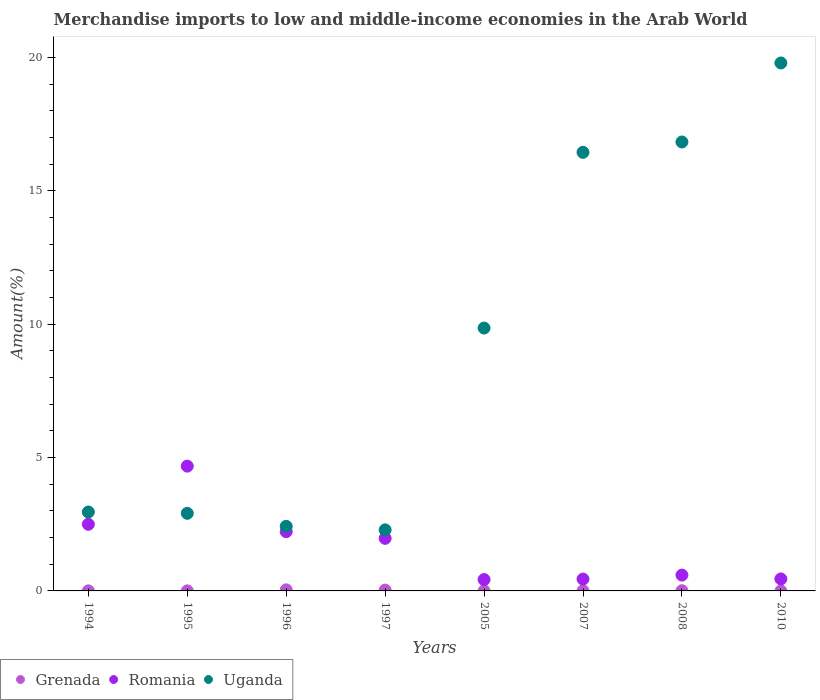Is the number of dotlines equal to the number of legend labels?
Offer a terse response. Yes. What is the percentage of amount earned from merchandise imports in Grenada in 2005?
Give a very brief answer. 0. Across all years, what is the maximum percentage of amount earned from merchandise imports in Uganda?
Your answer should be very brief. 19.8. Across all years, what is the minimum percentage of amount earned from merchandise imports in Grenada?
Make the answer very short. 6.59134036777357e-5. What is the total percentage of amount earned from merchandise imports in Uganda in the graph?
Provide a short and direct response. 73.52. What is the difference between the percentage of amount earned from merchandise imports in Uganda in 2005 and that in 2008?
Your answer should be compact. -6.98. What is the difference between the percentage of amount earned from merchandise imports in Romania in 1995 and the percentage of amount earned from merchandise imports in Uganda in 1996?
Your answer should be very brief. 2.26. What is the average percentage of amount earned from merchandise imports in Uganda per year?
Ensure brevity in your answer.  9.19. In the year 2005, what is the difference between the percentage of amount earned from merchandise imports in Romania and percentage of amount earned from merchandise imports in Uganda?
Give a very brief answer. -9.43. In how many years, is the percentage of amount earned from merchandise imports in Uganda greater than 10 %?
Ensure brevity in your answer.  3. What is the ratio of the percentage of amount earned from merchandise imports in Romania in 1994 to that in 1996?
Keep it short and to the point. 1.12. What is the difference between the highest and the second highest percentage of amount earned from merchandise imports in Uganda?
Keep it short and to the point. 2.96. What is the difference between the highest and the lowest percentage of amount earned from merchandise imports in Uganda?
Your answer should be very brief. 17.51. In how many years, is the percentage of amount earned from merchandise imports in Uganda greater than the average percentage of amount earned from merchandise imports in Uganda taken over all years?
Your answer should be compact. 4. Is it the case that in every year, the sum of the percentage of amount earned from merchandise imports in Grenada and percentage of amount earned from merchandise imports in Romania  is greater than the percentage of amount earned from merchandise imports in Uganda?
Ensure brevity in your answer.  No. Is the percentage of amount earned from merchandise imports in Romania strictly less than the percentage of amount earned from merchandise imports in Grenada over the years?
Provide a succinct answer. No. How many dotlines are there?
Offer a terse response. 3. How many years are there in the graph?
Give a very brief answer. 8. What is the difference between two consecutive major ticks on the Y-axis?
Make the answer very short. 5. Are the values on the major ticks of Y-axis written in scientific E-notation?
Ensure brevity in your answer.  No. Does the graph contain any zero values?
Your response must be concise. No. How many legend labels are there?
Give a very brief answer. 3. How are the legend labels stacked?
Your response must be concise. Horizontal. What is the title of the graph?
Keep it short and to the point. Merchandise imports to low and middle-income economies in the Arab World. What is the label or title of the X-axis?
Offer a very short reply. Years. What is the label or title of the Y-axis?
Provide a short and direct response. Amount(%). What is the Amount(%) in Grenada in 1994?
Make the answer very short. 0. What is the Amount(%) in Romania in 1994?
Keep it short and to the point. 2.5. What is the Amount(%) in Uganda in 1994?
Your answer should be very brief. 2.96. What is the Amount(%) of Grenada in 1995?
Ensure brevity in your answer.  0. What is the Amount(%) in Romania in 1995?
Your response must be concise. 4.68. What is the Amount(%) in Uganda in 1995?
Your answer should be compact. 2.91. What is the Amount(%) of Grenada in 1996?
Ensure brevity in your answer.  0.04. What is the Amount(%) in Romania in 1996?
Offer a very short reply. 2.22. What is the Amount(%) of Uganda in 1996?
Make the answer very short. 2.42. What is the Amount(%) of Grenada in 1997?
Offer a terse response. 0.03. What is the Amount(%) of Romania in 1997?
Keep it short and to the point. 1.97. What is the Amount(%) of Uganda in 1997?
Your answer should be very brief. 2.29. What is the Amount(%) of Grenada in 2005?
Provide a succinct answer. 0. What is the Amount(%) of Romania in 2005?
Your answer should be very brief. 0.43. What is the Amount(%) in Uganda in 2005?
Your response must be concise. 9.86. What is the Amount(%) of Grenada in 2007?
Ensure brevity in your answer.  0.01. What is the Amount(%) of Romania in 2007?
Offer a very short reply. 0.44. What is the Amount(%) in Uganda in 2007?
Your answer should be compact. 16.45. What is the Amount(%) of Grenada in 2008?
Give a very brief answer. 0.01. What is the Amount(%) in Romania in 2008?
Ensure brevity in your answer.  0.59. What is the Amount(%) of Uganda in 2008?
Offer a terse response. 16.84. What is the Amount(%) of Grenada in 2010?
Keep it short and to the point. 6.59134036777357e-5. What is the Amount(%) in Romania in 2010?
Provide a succinct answer. 0.45. What is the Amount(%) of Uganda in 2010?
Offer a terse response. 19.8. Across all years, what is the maximum Amount(%) in Grenada?
Your answer should be very brief. 0.04. Across all years, what is the maximum Amount(%) of Romania?
Your answer should be very brief. 4.68. Across all years, what is the maximum Amount(%) of Uganda?
Give a very brief answer. 19.8. Across all years, what is the minimum Amount(%) of Grenada?
Offer a very short reply. 6.59134036777357e-5. Across all years, what is the minimum Amount(%) in Romania?
Your response must be concise. 0.43. Across all years, what is the minimum Amount(%) of Uganda?
Make the answer very short. 2.29. What is the total Amount(%) in Grenada in the graph?
Provide a short and direct response. 0.09. What is the total Amount(%) in Romania in the graph?
Your answer should be very brief. 13.29. What is the total Amount(%) of Uganda in the graph?
Ensure brevity in your answer.  73.52. What is the difference between the Amount(%) of Romania in 1994 and that in 1995?
Provide a succinct answer. -2.18. What is the difference between the Amount(%) of Uganda in 1994 and that in 1995?
Offer a terse response. 0.05. What is the difference between the Amount(%) in Grenada in 1994 and that in 1996?
Your answer should be compact. -0.04. What is the difference between the Amount(%) in Romania in 1994 and that in 1996?
Give a very brief answer. 0.28. What is the difference between the Amount(%) in Uganda in 1994 and that in 1996?
Provide a short and direct response. 0.54. What is the difference between the Amount(%) in Grenada in 1994 and that in 1997?
Your answer should be compact. -0.03. What is the difference between the Amount(%) in Romania in 1994 and that in 1997?
Your answer should be very brief. 0.53. What is the difference between the Amount(%) of Uganda in 1994 and that in 1997?
Your answer should be very brief. 0.67. What is the difference between the Amount(%) of Grenada in 1994 and that in 2005?
Your answer should be very brief. -0. What is the difference between the Amount(%) of Romania in 1994 and that in 2005?
Your response must be concise. 2.07. What is the difference between the Amount(%) in Uganda in 1994 and that in 2005?
Provide a succinct answer. -6.9. What is the difference between the Amount(%) of Grenada in 1994 and that in 2007?
Provide a succinct answer. -0. What is the difference between the Amount(%) in Romania in 1994 and that in 2007?
Your answer should be compact. 2.05. What is the difference between the Amount(%) in Uganda in 1994 and that in 2007?
Make the answer very short. -13.49. What is the difference between the Amount(%) of Grenada in 1994 and that in 2008?
Give a very brief answer. -0. What is the difference between the Amount(%) of Romania in 1994 and that in 2008?
Ensure brevity in your answer.  1.9. What is the difference between the Amount(%) in Uganda in 1994 and that in 2008?
Your response must be concise. -13.88. What is the difference between the Amount(%) in Grenada in 1994 and that in 2010?
Give a very brief answer. 0. What is the difference between the Amount(%) of Romania in 1994 and that in 2010?
Give a very brief answer. 2.05. What is the difference between the Amount(%) of Uganda in 1994 and that in 2010?
Ensure brevity in your answer.  -16.84. What is the difference between the Amount(%) of Grenada in 1995 and that in 1996?
Your answer should be compact. -0.04. What is the difference between the Amount(%) in Romania in 1995 and that in 1996?
Provide a short and direct response. 2.46. What is the difference between the Amount(%) of Uganda in 1995 and that in 1996?
Offer a very short reply. 0.49. What is the difference between the Amount(%) in Grenada in 1995 and that in 1997?
Give a very brief answer. -0.03. What is the difference between the Amount(%) of Romania in 1995 and that in 1997?
Your response must be concise. 2.71. What is the difference between the Amount(%) of Uganda in 1995 and that in 1997?
Your answer should be compact. 0.62. What is the difference between the Amount(%) in Grenada in 1995 and that in 2005?
Your answer should be very brief. -0. What is the difference between the Amount(%) in Romania in 1995 and that in 2005?
Ensure brevity in your answer.  4.25. What is the difference between the Amount(%) in Uganda in 1995 and that in 2005?
Make the answer very short. -6.95. What is the difference between the Amount(%) of Grenada in 1995 and that in 2007?
Your answer should be compact. -0. What is the difference between the Amount(%) in Romania in 1995 and that in 2007?
Offer a terse response. 4.24. What is the difference between the Amount(%) of Uganda in 1995 and that in 2007?
Keep it short and to the point. -13.54. What is the difference between the Amount(%) of Grenada in 1995 and that in 2008?
Make the answer very short. -0. What is the difference between the Amount(%) of Romania in 1995 and that in 2008?
Your answer should be very brief. 4.09. What is the difference between the Amount(%) of Uganda in 1995 and that in 2008?
Offer a very short reply. -13.93. What is the difference between the Amount(%) of Grenada in 1995 and that in 2010?
Keep it short and to the point. 0. What is the difference between the Amount(%) of Romania in 1995 and that in 2010?
Keep it short and to the point. 4.23. What is the difference between the Amount(%) of Uganda in 1995 and that in 2010?
Keep it short and to the point. -16.89. What is the difference between the Amount(%) in Grenada in 1996 and that in 1997?
Your answer should be very brief. 0.01. What is the difference between the Amount(%) in Romania in 1996 and that in 1997?
Your answer should be compact. 0.25. What is the difference between the Amount(%) of Uganda in 1996 and that in 1997?
Your response must be concise. 0.13. What is the difference between the Amount(%) of Grenada in 1996 and that in 2005?
Your answer should be compact. 0.04. What is the difference between the Amount(%) of Romania in 1996 and that in 2005?
Provide a short and direct response. 1.8. What is the difference between the Amount(%) in Uganda in 1996 and that in 2005?
Offer a very short reply. -7.44. What is the difference between the Amount(%) in Grenada in 1996 and that in 2007?
Give a very brief answer. 0.04. What is the difference between the Amount(%) of Romania in 1996 and that in 2007?
Offer a terse response. 1.78. What is the difference between the Amount(%) of Uganda in 1996 and that in 2007?
Provide a succinct answer. -14.02. What is the difference between the Amount(%) of Grenada in 1996 and that in 2008?
Provide a short and direct response. 0.03. What is the difference between the Amount(%) of Romania in 1996 and that in 2008?
Provide a short and direct response. 1.63. What is the difference between the Amount(%) in Uganda in 1996 and that in 2008?
Provide a short and direct response. -14.41. What is the difference between the Amount(%) in Grenada in 1996 and that in 2010?
Make the answer very short. 0.04. What is the difference between the Amount(%) of Romania in 1996 and that in 2010?
Provide a short and direct response. 1.77. What is the difference between the Amount(%) of Uganda in 1996 and that in 2010?
Offer a very short reply. -17.38. What is the difference between the Amount(%) in Grenada in 1997 and that in 2005?
Offer a very short reply. 0.03. What is the difference between the Amount(%) in Romania in 1997 and that in 2005?
Make the answer very short. 1.55. What is the difference between the Amount(%) of Uganda in 1997 and that in 2005?
Your answer should be compact. -7.57. What is the difference between the Amount(%) of Grenada in 1997 and that in 2007?
Provide a short and direct response. 0.03. What is the difference between the Amount(%) of Romania in 1997 and that in 2007?
Provide a succinct answer. 1.53. What is the difference between the Amount(%) of Uganda in 1997 and that in 2007?
Keep it short and to the point. -14.16. What is the difference between the Amount(%) of Grenada in 1997 and that in 2008?
Your response must be concise. 0.02. What is the difference between the Amount(%) in Romania in 1997 and that in 2008?
Your response must be concise. 1.38. What is the difference between the Amount(%) in Uganda in 1997 and that in 2008?
Ensure brevity in your answer.  -14.54. What is the difference between the Amount(%) in Grenada in 1997 and that in 2010?
Your response must be concise. 0.03. What is the difference between the Amount(%) in Romania in 1997 and that in 2010?
Provide a succinct answer. 1.52. What is the difference between the Amount(%) in Uganda in 1997 and that in 2010?
Keep it short and to the point. -17.51. What is the difference between the Amount(%) in Grenada in 2005 and that in 2007?
Keep it short and to the point. -0. What is the difference between the Amount(%) in Romania in 2005 and that in 2007?
Make the answer very short. -0.02. What is the difference between the Amount(%) in Uganda in 2005 and that in 2007?
Your answer should be very brief. -6.59. What is the difference between the Amount(%) in Grenada in 2005 and that in 2008?
Provide a succinct answer. -0. What is the difference between the Amount(%) in Romania in 2005 and that in 2008?
Your answer should be very brief. -0.17. What is the difference between the Amount(%) of Uganda in 2005 and that in 2008?
Your response must be concise. -6.98. What is the difference between the Amount(%) of Grenada in 2005 and that in 2010?
Provide a succinct answer. 0. What is the difference between the Amount(%) in Romania in 2005 and that in 2010?
Your answer should be very brief. -0.02. What is the difference between the Amount(%) of Uganda in 2005 and that in 2010?
Ensure brevity in your answer.  -9.94. What is the difference between the Amount(%) of Grenada in 2007 and that in 2008?
Keep it short and to the point. -0. What is the difference between the Amount(%) of Romania in 2007 and that in 2008?
Provide a short and direct response. -0.15. What is the difference between the Amount(%) of Uganda in 2007 and that in 2008?
Give a very brief answer. -0.39. What is the difference between the Amount(%) of Grenada in 2007 and that in 2010?
Offer a terse response. 0.01. What is the difference between the Amount(%) of Romania in 2007 and that in 2010?
Provide a succinct answer. -0.01. What is the difference between the Amount(%) of Uganda in 2007 and that in 2010?
Keep it short and to the point. -3.35. What is the difference between the Amount(%) in Grenada in 2008 and that in 2010?
Make the answer very short. 0.01. What is the difference between the Amount(%) of Romania in 2008 and that in 2010?
Ensure brevity in your answer.  0.14. What is the difference between the Amount(%) in Uganda in 2008 and that in 2010?
Provide a succinct answer. -2.96. What is the difference between the Amount(%) of Grenada in 1994 and the Amount(%) of Romania in 1995?
Offer a terse response. -4.68. What is the difference between the Amount(%) of Grenada in 1994 and the Amount(%) of Uganda in 1995?
Your response must be concise. -2.91. What is the difference between the Amount(%) of Romania in 1994 and the Amount(%) of Uganda in 1995?
Offer a very short reply. -0.41. What is the difference between the Amount(%) in Grenada in 1994 and the Amount(%) in Romania in 1996?
Ensure brevity in your answer.  -2.22. What is the difference between the Amount(%) in Grenada in 1994 and the Amount(%) in Uganda in 1996?
Offer a very short reply. -2.42. What is the difference between the Amount(%) of Romania in 1994 and the Amount(%) of Uganda in 1996?
Provide a short and direct response. 0.08. What is the difference between the Amount(%) of Grenada in 1994 and the Amount(%) of Romania in 1997?
Give a very brief answer. -1.97. What is the difference between the Amount(%) of Grenada in 1994 and the Amount(%) of Uganda in 1997?
Your answer should be compact. -2.29. What is the difference between the Amount(%) of Romania in 1994 and the Amount(%) of Uganda in 1997?
Offer a terse response. 0.21. What is the difference between the Amount(%) of Grenada in 1994 and the Amount(%) of Romania in 2005?
Keep it short and to the point. -0.42. What is the difference between the Amount(%) in Grenada in 1994 and the Amount(%) in Uganda in 2005?
Offer a terse response. -9.86. What is the difference between the Amount(%) of Romania in 1994 and the Amount(%) of Uganda in 2005?
Offer a very short reply. -7.36. What is the difference between the Amount(%) in Grenada in 1994 and the Amount(%) in Romania in 2007?
Keep it short and to the point. -0.44. What is the difference between the Amount(%) in Grenada in 1994 and the Amount(%) in Uganda in 2007?
Your response must be concise. -16.44. What is the difference between the Amount(%) in Romania in 1994 and the Amount(%) in Uganda in 2007?
Give a very brief answer. -13.95. What is the difference between the Amount(%) in Grenada in 1994 and the Amount(%) in Romania in 2008?
Your answer should be very brief. -0.59. What is the difference between the Amount(%) in Grenada in 1994 and the Amount(%) in Uganda in 2008?
Ensure brevity in your answer.  -16.83. What is the difference between the Amount(%) of Romania in 1994 and the Amount(%) of Uganda in 2008?
Offer a very short reply. -14.34. What is the difference between the Amount(%) of Grenada in 1994 and the Amount(%) of Romania in 2010?
Your response must be concise. -0.45. What is the difference between the Amount(%) in Grenada in 1994 and the Amount(%) in Uganda in 2010?
Provide a succinct answer. -19.8. What is the difference between the Amount(%) of Romania in 1994 and the Amount(%) of Uganda in 2010?
Keep it short and to the point. -17.3. What is the difference between the Amount(%) of Grenada in 1995 and the Amount(%) of Romania in 1996?
Provide a short and direct response. -2.22. What is the difference between the Amount(%) in Grenada in 1995 and the Amount(%) in Uganda in 1996?
Offer a very short reply. -2.42. What is the difference between the Amount(%) of Romania in 1995 and the Amount(%) of Uganda in 1996?
Give a very brief answer. 2.26. What is the difference between the Amount(%) in Grenada in 1995 and the Amount(%) in Romania in 1997?
Offer a very short reply. -1.97. What is the difference between the Amount(%) of Grenada in 1995 and the Amount(%) of Uganda in 1997?
Offer a terse response. -2.29. What is the difference between the Amount(%) in Romania in 1995 and the Amount(%) in Uganda in 1997?
Offer a terse response. 2.39. What is the difference between the Amount(%) in Grenada in 1995 and the Amount(%) in Romania in 2005?
Provide a short and direct response. -0.42. What is the difference between the Amount(%) of Grenada in 1995 and the Amount(%) of Uganda in 2005?
Ensure brevity in your answer.  -9.86. What is the difference between the Amount(%) in Romania in 1995 and the Amount(%) in Uganda in 2005?
Your response must be concise. -5.18. What is the difference between the Amount(%) in Grenada in 1995 and the Amount(%) in Romania in 2007?
Provide a succinct answer. -0.44. What is the difference between the Amount(%) of Grenada in 1995 and the Amount(%) of Uganda in 2007?
Provide a succinct answer. -16.45. What is the difference between the Amount(%) of Romania in 1995 and the Amount(%) of Uganda in 2007?
Make the answer very short. -11.77. What is the difference between the Amount(%) in Grenada in 1995 and the Amount(%) in Romania in 2008?
Offer a very short reply. -0.59. What is the difference between the Amount(%) of Grenada in 1995 and the Amount(%) of Uganda in 2008?
Provide a succinct answer. -16.83. What is the difference between the Amount(%) of Romania in 1995 and the Amount(%) of Uganda in 2008?
Keep it short and to the point. -12.16. What is the difference between the Amount(%) in Grenada in 1995 and the Amount(%) in Romania in 2010?
Give a very brief answer. -0.45. What is the difference between the Amount(%) in Grenada in 1995 and the Amount(%) in Uganda in 2010?
Provide a succinct answer. -19.8. What is the difference between the Amount(%) of Romania in 1995 and the Amount(%) of Uganda in 2010?
Offer a terse response. -15.12. What is the difference between the Amount(%) in Grenada in 1996 and the Amount(%) in Romania in 1997?
Offer a very short reply. -1.93. What is the difference between the Amount(%) of Grenada in 1996 and the Amount(%) of Uganda in 1997?
Give a very brief answer. -2.25. What is the difference between the Amount(%) of Romania in 1996 and the Amount(%) of Uganda in 1997?
Offer a terse response. -0.07. What is the difference between the Amount(%) in Grenada in 1996 and the Amount(%) in Romania in 2005?
Provide a short and direct response. -0.39. What is the difference between the Amount(%) of Grenada in 1996 and the Amount(%) of Uganda in 2005?
Make the answer very short. -9.82. What is the difference between the Amount(%) in Romania in 1996 and the Amount(%) in Uganda in 2005?
Your response must be concise. -7.64. What is the difference between the Amount(%) in Grenada in 1996 and the Amount(%) in Romania in 2007?
Provide a succinct answer. -0.4. What is the difference between the Amount(%) of Grenada in 1996 and the Amount(%) of Uganda in 2007?
Provide a succinct answer. -16.41. What is the difference between the Amount(%) of Romania in 1996 and the Amount(%) of Uganda in 2007?
Your response must be concise. -14.22. What is the difference between the Amount(%) of Grenada in 1996 and the Amount(%) of Romania in 2008?
Offer a very short reply. -0.55. What is the difference between the Amount(%) of Grenada in 1996 and the Amount(%) of Uganda in 2008?
Your answer should be very brief. -16.79. What is the difference between the Amount(%) in Romania in 1996 and the Amount(%) in Uganda in 2008?
Provide a succinct answer. -14.61. What is the difference between the Amount(%) of Grenada in 1996 and the Amount(%) of Romania in 2010?
Provide a short and direct response. -0.41. What is the difference between the Amount(%) in Grenada in 1996 and the Amount(%) in Uganda in 2010?
Provide a succinct answer. -19.76. What is the difference between the Amount(%) in Romania in 1996 and the Amount(%) in Uganda in 2010?
Make the answer very short. -17.58. What is the difference between the Amount(%) of Grenada in 1997 and the Amount(%) of Romania in 2005?
Your response must be concise. -0.4. What is the difference between the Amount(%) of Grenada in 1997 and the Amount(%) of Uganda in 2005?
Make the answer very short. -9.83. What is the difference between the Amount(%) in Romania in 1997 and the Amount(%) in Uganda in 2005?
Provide a short and direct response. -7.89. What is the difference between the Amount(%) of Grenada in 1997 and the Amount(%) of Romania in 2007?
Provide a succinct answer. -0.41. What is the difference between the Amount(%) of Grenada in 1997 and the Amount(%) of Uganda in 2007?
Make the answer very short. -16.42. What is the difference between the Amount(%) of Romania in 1997 and the Amount(%) of Uganda in 2007?
Ensure brevity in your answer.  -14.48. What is the difference between the Amount(%) in Grenada in 1997 and the Amount(%) in Romania in 2008?
Provide a succinct answer. -0.56. What is the difference between the Amount(%) of Grenada in 1997 and the Amount(%) of Uganda in 2008?
Provide a short and direct response. -16.8. What is the difference between the Amount(%) of Romania in 1997 and the Amount(%) of Uganda in 2008?
Provide a short and direct response. -14.86. What is the difference between the Amount(%) in Grenada in 1997 and the Amount(%) in Romania in 2010?
Give a very brief answer. -0.42. What is the difference between the Amount(%) in Grenada in 1997 and the Amount(%) in Uganda in 2010?
Make the answer very short. -19.77. What is the difference between the Amount(%) in Romania in 1997 and the Amount(%) in Uganda in 2010?
Offer a very short reply. -17.83. What is the difference between the Amount(%) in Grenada in 2005 and the Amount(%) in Romania in 2007?
Your response must be concise. -0.44. What is the difference between the Amount(%) of Grenada in 2005 and the Amount(%) of Uganda in 2007?
Give a very brief answer. -16.44. What is the difference between the Amount(%) in Romania in 2005 and the Amount(%) in Uganda in 2007?
Provide a short and direct response. -16.02. What is the difference between the Amount(%) in Grenada in 2005 and the Amount(%) in Romania in 2008?
Ensure brevity in your answer.  -0.59. What is the difference between the Amount(%) of Grenada in 2005 and the Amount(%) of Uganda in 2008?
Offer a very short reply. -16.83. What is the difference between the Amount(%) in Romania in 2005 and the Amount(%) in Uganda in 2008?
Your response must be concise. -16.41. What is the difference between the Amount(%) of Grenada in 2005 and the Amount(%) of Romania in 2010?
Your answer should be compact. -0.45. What is the difference between the Amount(%) of Grenada in 2005 and the Amount(%) of Uganda in 2010?
Give a very brief answer. -19.79. What is the difference between the Amount(%) of Romania in 2005 and the Amount(%) of Uganda in 2010?
Your response must be concise. -19.37. What is the difference between the Amount(%) in Grenada in 2007 and the Amount(%) in Romania in 2008?
Make the answer very short. -0.59. What is the difference between the Amount(%) of Grenada in 2007 and the Amount(%) of Uganda in 2008?
Provide a short and direct response. -16.83. What is the difference between the Amount(%) in Romania in 2007 and the Amount(%) in Uganda in 2008?
Give a very brief answer. -16.39. What is the difference between the Amount(%) in Grenada in 2007 and the Amount(%) in Romania in 2010?
Provide a short and direct response. -0.44. What is the difference between the Amount(%) in Grenada in 2007 and the Amount(%) in Uganda in 2010?
Your answer should be compact. -19.79. What is the difference between the Amount(%) of Romania in 2007 and the Amount(%) of Uganda in 2010?
Provide a short and direct response. -19.35. What is the difference between the Amount(%) of Grenada in 2008 and the Amount(%) of Romania in 2010?
Offer a terse response. -0.44. What is the difference between the Amount(%) of Grenada in 2008 and the Amount(%) of Uganda in 2010?
Give a very brief answer. -19.79. What is the difference between the Amount(%) in Romania in 2008 and the Amount(%) in Uganda in 2010?
Provide a succinct answer. -19.2. What is the average Amount(%) of Grenada per year?
Provide a short and direct response. 0.01. What is the average Amount(%) of Romania per year?
Provide a succinct answer. 1.66. What is the average Amount(%) of Uganda per year?
Your answer should be compact. 9.19. In the year 1994, what is the difference between the Amount(%) of Grenada and Amount(%) of Romania?
Keep it short and to the point. -2.5. In the year 1994, what is the difference between the Amount(%) of Grenada and Amount(%) of Uganda?
Your response must be concise. -2.96. In the year 1994, what is the difference between the Amount(%) in Romania and Amount(%) in Uganda?
Make the answer very short. -0.46. In the year 1995, what is the difference between the Amount(%) in Grenada and Amount(%) in Romania?
Offer a very short reply. -4.68. In the year 1995, what is the difference between the Amount(%) of Grenada and Amount(%) of Uganda?
Make the answer very short. -2.91. In the year 1995, what is the difference between the Amount(%) of Romania and Amount(%) of Uganda?
Give a very brief answer. 1.77. In the year 1996, what is the difference between the Amount(%) in Grenada and Amount(%) in Romania?
Keep it short and to the point. -2.18. In the year 1996, what is the difference between the Amount(%) of Grenada and Amount(%) of Uganda?
Your answer should be compact. -2.38. In the year 1996, what is the difference between the Amount(%) of Romania and Amount(%) of Uganda?
Offer a terse response. -0.2. In the year 1997, what is the difference between the Amount(%) in Grenada and Amount(%) in Romania?
Your response must be concise. -1.94. In the year 1997, what is the difference between the Amount(%) in Grenada and Amount(%) in Uganda?
Provide a succinct answer. -2.26. In the year 1997, what is the difference between the Amount(%) of Romania and Amount(%) of Uganda?
Offer a very short reply. -0.32. In the year 2005, what is the difference between the Amount(%) in Grenada and Amount(%) in Romania?
Give a very brief answer. -0.42. In the year 2005, what is the difference between the Amount(%) of Grenada and Amount(%) of Uganda?
Provide a succinct answer. -9.85. In the year 2005, what is the difference between the Amount(%) in Romania and Amount(%) in Uganda?
Provide a short and direct response. -9.43. In the year 2007, what is the difference between the Amount(%) in Grenada and Amount(%) in Romania?
Your answer should be very brief. -0.44. In the year 2007, what is the difference between the Amount(%) of Grenada and Amount(%) of Uganda?
Give a very brief answer. -16.44. In the year 2007, what is the difference between the Amount(%) in Romania and Amount(%) in Uganda?
Your answer should be compact. -16. In the year 2008, what is the difference between the Amount(%) of Grenada and Amount(%) of Romania?
Make the answer very short. -0.59. In the year 2008, what is the difference between the Amount(%) in Grenada and Amount(%) in Uganda?
Your answer should be compact. -16.83. In the year 2008, what is the difference between the Amount(%) in Romania and Amount(%) in Uganda?
Make the answer very short. -16.24. In the year 2010, what is the difference between the Amount(%) of Grenada and Amount(%) of Romania?
Make the answer very short. -0.45. In the year 2010, what is the difference between the Amount(%) of Grenada and Amount(%) of Uganda?
Your answer should be very brief. -19.8. In the year 2010, what is the difference between the Amount(%) of Romania and Amount(%) of Uganda?
Ensure brevity in your answer.  -19.35. What is the ratio of the Amount(%) of Grenada in 1994 to that in 1995?
Your answer should be compact. 1.19. What is the ratio of the Amount(%) in Romania in 1994 to that in 1995?
Provide a succinct answer. 0.53. What is the ratio of the Amount(%) in Uganda in 1994 to that in 1995?
Your response must be concise. 1.02. What is the ratio of the Amount(%) of Grenada in 1994 to that in 1996?
Your answer should be very brief. 0.06. What is the ratio of the Amount(%) of Romania in 1994 to that in 1996?
Ensure brevity in your answer.  1.12. What is the ratio of the Amount(%) in Uganda in 1994 to that in 1996?
Offer a terse response. 1.22. What is the ratio of the Amount(%) in Grenada in 1994 to that in 1997?
Provide a short and direct response. 0.08. What is the ratio of the Amount(%) in Romania in 1994 to that in 1997?
Provide a succinct answer. 1.27. What is the ratio of the Amount(%) of Uganda in 1994 to that in 1997?
Offer a very short reply. 1.29. What is the ratio of the Amount(%) of Grenada in 1994 to that in 2005?
Make the answer very short. 0.5. What is the ratio of the Amount(%) of Romania in 1994 to that in 2005?
Offer a very short reply. 5.86. What is the ratio of the Amount(%) in Uganda in 1994 to that in 2005?
Provide a short and direct response. 0.3. What is the ratio of the Amount(%) in Grenada in 1994 to that in 2007?
Offer a very short reply. 0.39. What is the ratio of the Amount(%) in Romania in 1994 to that in 2007?
Provide a short and direct response. 5.62. What is the ratio of the Amount(%) of Uganda in 1994 to that in 2007?
Offer a terse response. 0.18. What is the ratio of the Amount(%) in Grenada in 1994 to that in 2008?
Your response must be concise. 0.35. What is the ratio of the Amount(%) of Romania in 1994 to that in 2008?
Offer a very short reply. 4.21. What is the ratio of the Amount(%) in Uganda in 1994 to that in 2008?
Your answer should be very brief. 0.18. What is the ratio of the Amount(%) in Grenada in 1994 to that in 2010?
Make the answer very short. 35.23. What is the ratio of the Amount(%) in Romania in 1994 to that in 2010?
Provide a short and direct response. 5.55. What is the ratio of the Amount(%) of Uganda in 1994 to that in 2010?
Keep it short and to the point. 0.15. What is the ratio of the Amount(%) in Grenada in 1995 to that in 1996?
Make the answer very short. 0.05. What is the ratio of the Amount(%) of Romania in 1995 to that in 1996?
Offer a terse response. 2.11. What is the ratio of the Amount(%) of Uganda in 1995 to that in 1996?
Ensure brevity in your answer.  1.2. What is the ratio of the Amount(%) of Grenada in 1995 to that in 1997?
Give a very brief answer. 0.06. What is the ratio of the Amount(%) in Romania in 1995 to that in 1997?
Your response must be concise. 2.37. What is the ratio of the Amount(%) of Uganda in 1995 to that in 1997?
Give a very brief answer. 1.27. What is the ratio of the Amount(%) in Grenada in 1995 to that in 2005?
Your answer should be very brief. 0.42. What is the ratio of the Amount(%) in Romania in 1995 to that in 2005?
Provide a succinct answer. 10.98. What is the ratio of the Amount(%) of Uganda in 1995 to that in 2005?
Make the answer very short. 0.3. What is the ratio of the Amount(%) in Grenada in 1995 to that in 2007?
Your answer should be compact. 0.33. What is the ratio of the Amount(%) of Romania in 1995 to that in 2007?
Keep it short and to the point. 10.53. What is the ratio of the Amount(%) in Uganda in 1995 to that in 2007?
Keep it short and to the point. 0.18. What is the ratio of the Amount(%) of Grenada in 1995 to that in 2008?
Ensure brevity in your answer.  0.29. What is the ratio of the Amount(%) of Romania in 1995 to that in 2008?
Your answer should be compact. 7.88. What is the ratio of the Amount(%) in Uganda in 1995 to that in 2008?
Your answer should be very brief. 0.17. What is the ratio of the Amount(%) in Grenada in 1995 to that in 2010?
Give a very brief answer. 29.69. What is the ratio of the Amount(%) in Romania in 1995 to that in 2010?
Make the answer very short. 10.4. What is the ratio of the Amount(%) in Uganda in 1995 to that in 2010?
Offer a terse response. 0.15. What is the ratio of the Amount(%) in Grenada in 1996 to that in 1997?
Your response must be concise. 1.33. What is the ratio of the Amount(%) of Romania in 1996 to that in 1997?
Make the answer very short. 1.13. What is the ratio of the Amount(%) of Uganda in 1996 to that in 1997?
Ensure brevity in your answer.  1.06. What is the ratio of the Amount(%) of Grenada in 1996 to that in 2005?
Offer a terse response. 8.86. What is the ratio of the Amount(%) of Romania in 1996 to that in 2005?
Your response must be concise. 5.21. What is the ratio of the Amount(%) in Uganda in 1996 to that in 2005?
Offer a very short reply. 0.25. What is the ratio of the Amount(%) in Grenada in 1996 to that in 2007?
Your response must be concise. 6.94. What is the ratio of the Amount(%) of Romania in 1996 to that in 2007?
Your response must be concise. 5. What is the ratio of the Amount(%) of Uganda in 1996 to that in 2007?
Provide a succinct answer. 0.15. What is the ratio of the Amount(%) of Grenada in 1996 to that in 2008?
Offer a terse response. 6.15. What is the ratio of the Amount(%) of Romania in 1996 to that in 2008?
Provide a short and direct response. 3.74. What is the ratio of the Amount(%) of Uganda in 1996 to that in 2008?
Make the answer very short. 0.14. What is the ratio of the Amount(%) in Grenada in 1996 to that in 2010?
Offer a terse response. 625.88. What is the ratio of the Amount(%) in Romania in 1996 to that in 2010?
Keep it short and to the point. 4.94. What is the ratio of the Amount(%) of Uganda in 1996 to that in 2010?
Provide a short and direct response. 0.12. What is the ratio of the Amount(%) of Grenada in 1997 to that in 2005?
Offer a terse response. 6.64. What is the ratio of the Amount(%) of Romania in 1997 to that in 2005?
Your answer should be compact. 4.63. What is the ratio of the Amount(%) in Uganda in 1997 to that in 2005?
Your answer should be very brief. 0.23. What is the ratio of the Amount(%) of Grenada in 1997 to that in 2007?
Keep it short and to the point. 5.2. What is the ratio of the Amount(%) of Romania in 1997 to that in 2007?
Offer a terse response. 4.44. What is the ratio of the Amount(%) of Uganda in 1997 to that in 2007?
Ensure brevity in your answer.  0.14. What is the ratio of the Amount(%) in Grenada in 1997 to that in 2008?
Provide a short and direct response. 4.61. What is the ratio of the Amount(%) of Romania in 1997 to that in 2008?
Give a very brief answer. 3.32. What is the ratio of the Amount(%) of Uganda in 1997 to that in 2008?
Provide a short and direct response. 0.14. What is the ratio of the Amount(%) in Grenada in 1997 to that in 2010?
Make the answer very short. 469.19. What is the ratio of the Amount(%) of Romania in 1997 to that in 2010?
Make the answer very short. 4.38. What is the ratio of the Amount(%) of Uganda in 1997 to that in 2010?
Your answer should be compact. 0.12. What is the ratio of the Amount(%) in Grenada in 2005 to that in 2007?
Your answer should be very brief. 0.78. What is the ratio of the Amount(%) of Romania in 2005 to that in 2007?
Ensure brevity in your answer.  0.96. What is the ratio of the Amount(%) of Uganda in 2005 to that in 2007?
Your answer should be very brief. 0.6. What is the ratio of the Amount(%) of Grenada in 2005 to that in 2008?
Provide a short and direct response. 0.69. What is the ratio of the Amount(%) of Romania in 2005 to that in 2008?
Offer a very short reply. 0.72. What is the ratio of the Amount(%) of Uganda in 2005 to that in 2008?
Provide a short and direct response. 0.59. What is the ratio of the Amount(%) in Grenada in 2005 to that in 2010?
Keep it short and to the point. 70.66. What is the ratio of the Amount(%) of Romania in 2005 to that in 2010?
Your response must be concise. 0.95. What is the ratio of the Amount(%) in Uganda in 2005 to that in 2010?
Your answer should be compact. 0.5. What is the ratio of the Amount(%) of Grenada in 2007 to that in 2008?
Your answer should be compact. 0.89. What is the ratio of the Amount(%) in Romania in 2007 to that in 2008?
Offer a terse response. 0.75. What is the ratio of the Amount(%) of Uganda in 2007 to that in 2008?
Give a very brief answer. 0.98. What is the ratio of the Amount(%) in Grenada in 2007 to that in 2010?
Provide a succinct answer. 90.19. What is the ratio of the Amount(%) in Romania in 2007 to that in 2010?
Keep it short and to the point. 0.99. What is the ratio of the Amount(%) of Uganda in 2007 to that in 2010?
Your answer should be very brief. 0.83. What is the ratio of the Amount(%) of Grenada in 2008 to that in 2010?
Your answer should be compact. 101.85. What is the ratio of the Amount(%) in Romania in 2008 to that in 2010?
Your response must be concise. 1.32. What is the ratio of the Amount(%) in Uganda in 2008 to that in 2010?
Provide a short and direct response. 0.85. What is the difference between the highest and the second highest Amount(%) in Grenada?
Your answer should be very brief. 0.01. What is the difference between the highest and the second highest Amount(%) in Romania?
Offer a terse response. 2.18. What is the difference between the highest and the second highest Amount(%) of Uganda?
Keep it short and to the point. 2.96. What is the difference between the highest and the lowest Amount(%) in Grenada?
Your response must be concise. 0.04. What is the difference between the highest and the lowest Amount(%) of Romania?
Offer a very short reply. 4.25. What is the difference between the highest and the lowest Amount(%) in Uganda?
Offer a terse response. 17.51. 